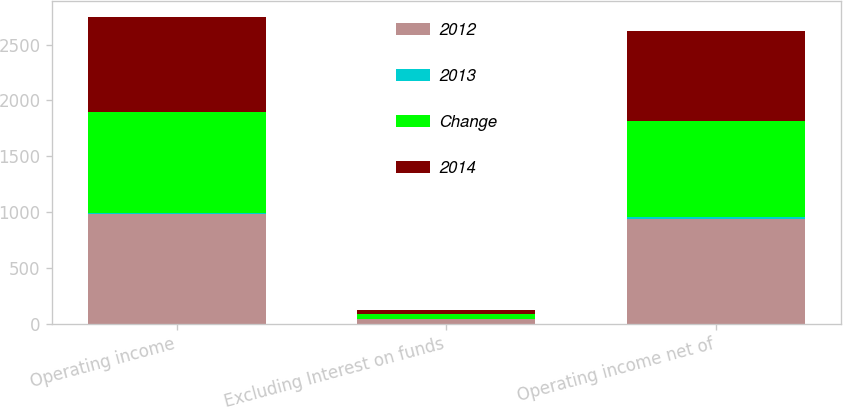<chart> <loc_0><loc_0><loc_500><loc_500><stacked_bar_chart><ecel><fcel>Operating income<fcel>Excluding Interest on funds<fcel>Operating income net of<nl><fcel>2012<fcel>982.7<fcel>40.7<fcel>942<nl><fcel>2013<fcel>9<fcel>1<fcel>9<nl><fcel>Change<fcel>904.8<fcel>41<fcel>863.8<nl><fcel>2014<fcel>853.9<fcel>43.6<fcel>810.3<nl></chart> 